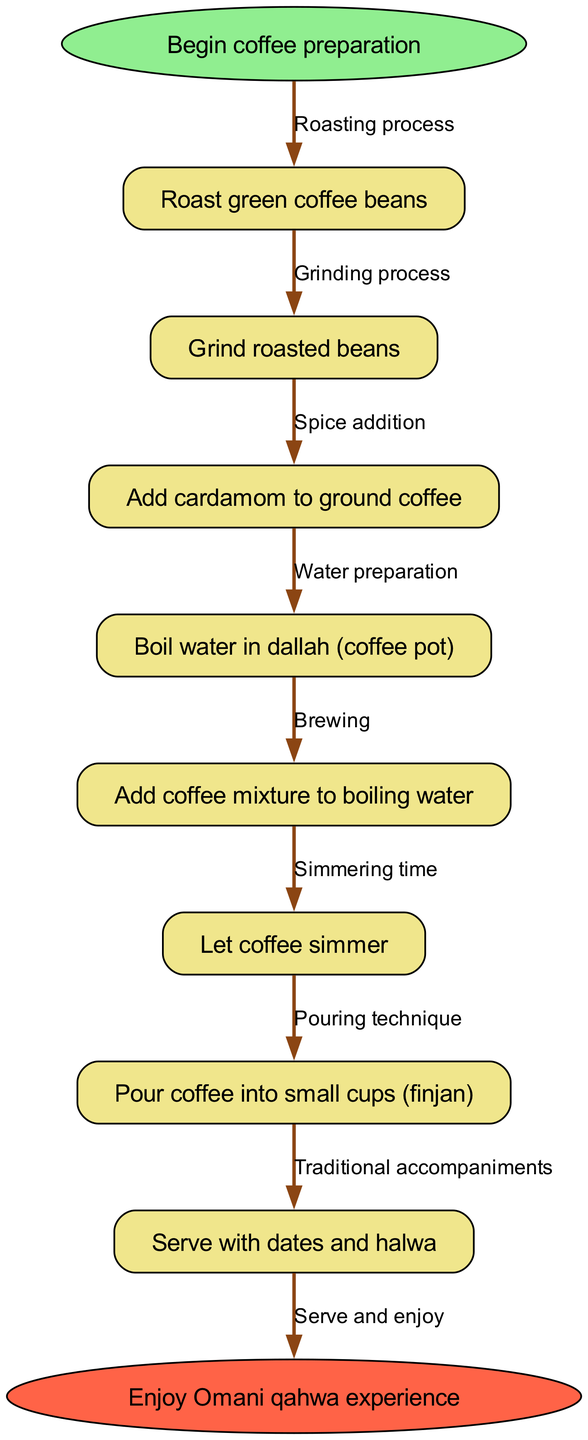What is the first step in the coffee preparation workflow? The first step indicated in the diagram is "Roast green coffee beans," which is directly connected to the start node.
Answer: Roast green coffee beans How many nodes are present in the workflow diagram? Counting the total number of nodes, which includes the start, all process steps, and the end node, there are 9 nodes in total.
Answer: 9 What is the last step mentioned in the workflow? The final step is indicated by the end node, which summarizes the experience with "Enjoy Omani qahwa experience."
Answer: Enjoy Omani qahwa experience What process follows after grinding the roasted beans? According to the flow, after "Grind roasted beans," the next process involved is "Add cardamom to ground coffee."
Answer: Add cardamom to ground coffee What connects the "Let coffee simmer" node to the "Serve with dates and halwa" node? The node "Let coffee simmer" is connected to the "Pour coffee into small cups (finjan)" node, which then leads to the serving process, denoting a sequence of actions.
Answer: Pour coffee into small cups (finjan) What edge describes the transition from boiling water to adding the coffee mixture? The edge that describes this transition is labeled "Brewing," connecting "Add coffee mixture to boiling water" with the next step.
Answer: Brewing What is the specific spice added to the coffee mixture? The diagram indicates that "cardamom" is the specific spice added to the ground coffee mixture during preparation.
Answer: cardamom How many edges are represented in the diagram? There are 8 edges in total connecting the nodes, as each process depends on the preceding step to facilitate the workflow.
Answer: 8 Which process involves traditional accompaniments? The final node "Serve with dates and halwa" specifies that traditional accompaniments are included in this process, indicating cultural significance.
Answer: Serve with dates and halwa 